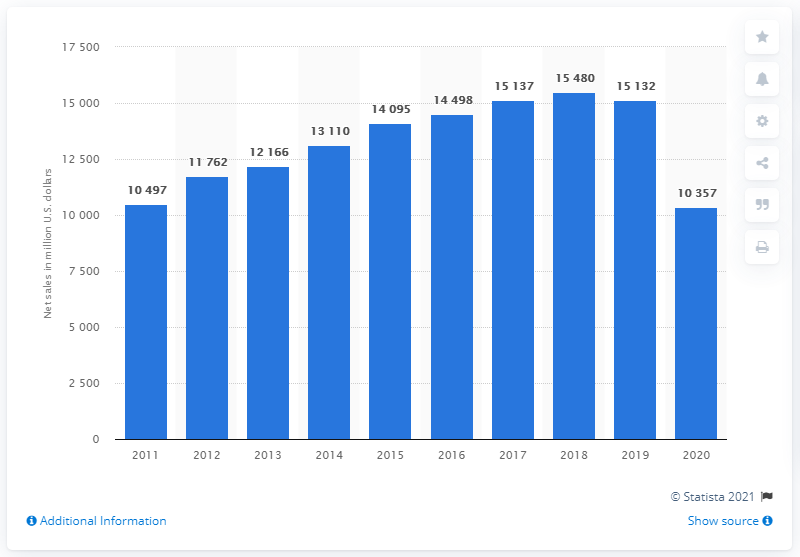Outline some significant characteristics in this image. In 2020, Nordstrom's global net sales were approximately $10,357 in dollars. 